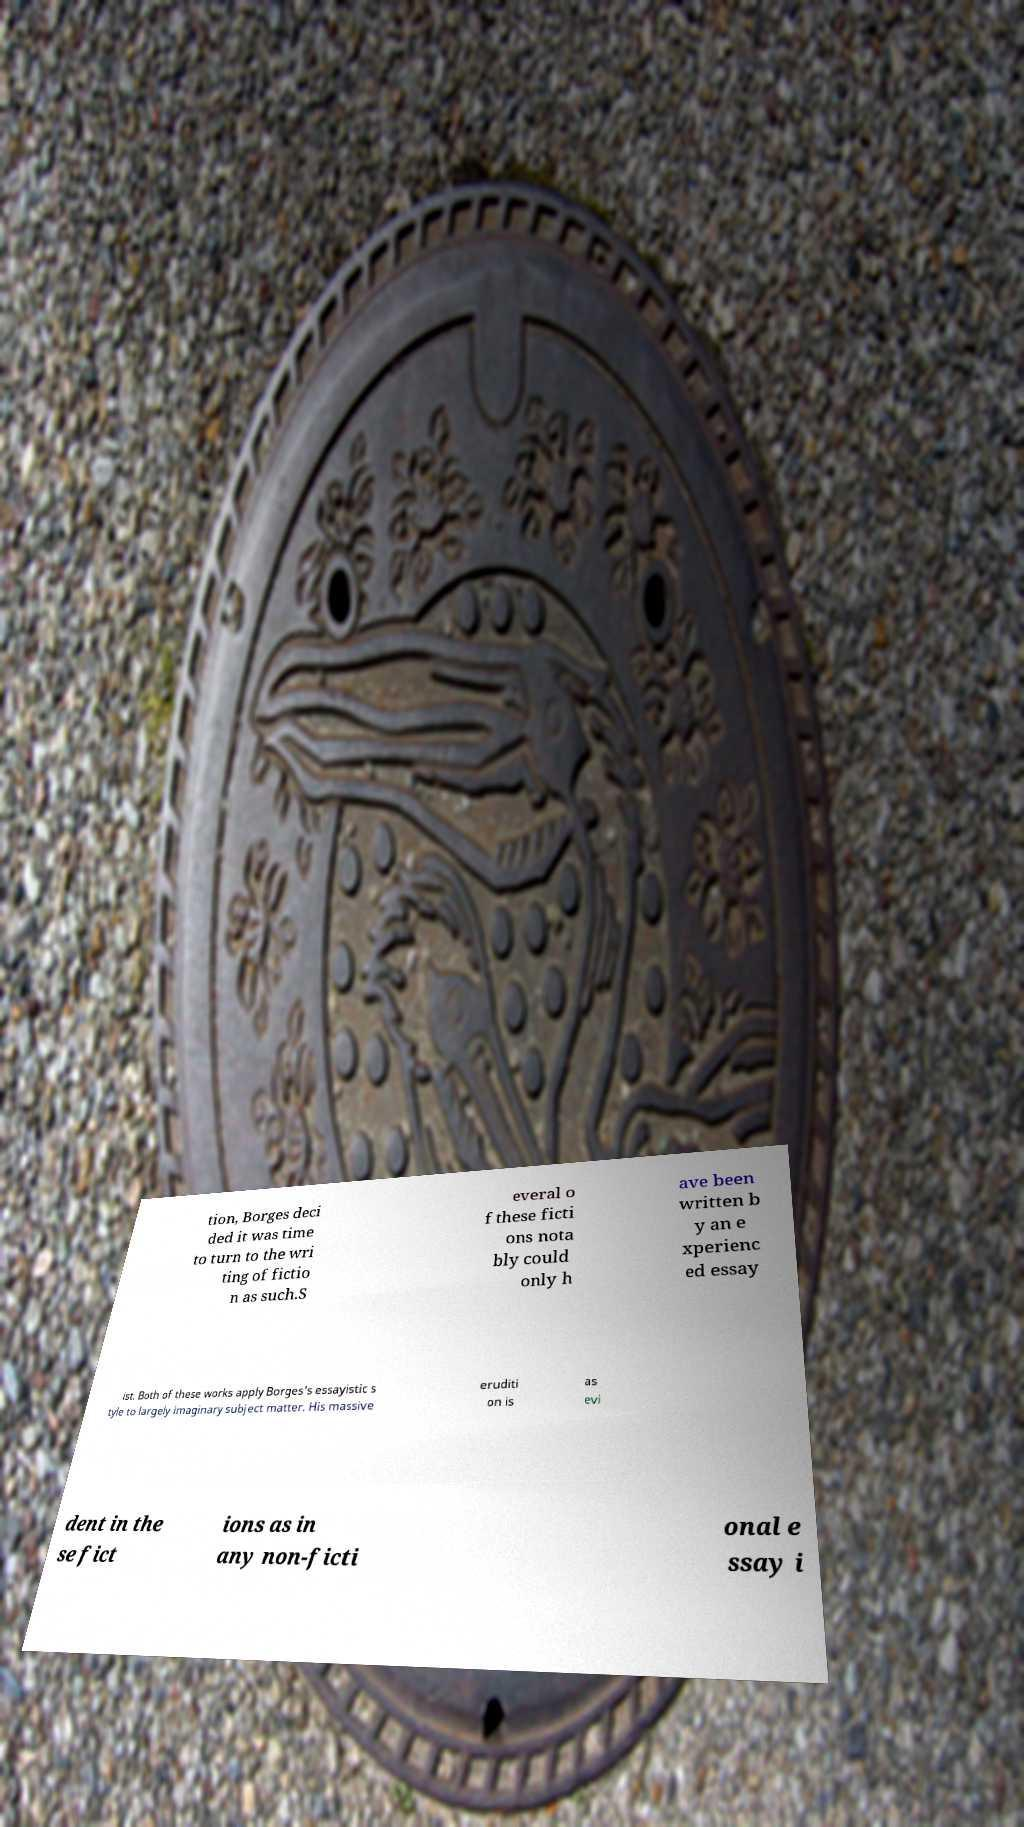Could you assist in decoding the text presented in this image and type it out clearly? tion, Borges deci ded it was time to turn to the wri ting of fictio n as such.S everal o f these ficti ons nota bly could only h ave been written b y an e xperienc ed essay ist. Both of these works apply Borges's essayistic s tyle to largely imaginary subject matter. His massive eruditi on is as evi dent in the se fict ions as in any non-ficti onal e ssay i 